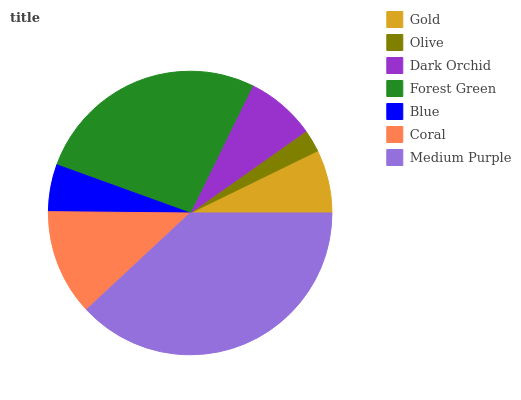Is Olive the minimum?
Answer yes or no. Yes. Is Medium Purple the maximum?
Answer yes or no. Yes. Is Dark Orchid the minimum?
Answer yes or no. No. Is Dark Orchid the maximum?
Answer yes or no. No. Is Dark Orchid greater than Olive?
Answer yes or no. Yes. Is Olive less than Dark Orchid?
Answer yes or no. Yes. Is Olive greater than Dark Orchid?
Answer yes or no. No. Is Dark Orchid less than Olive?
Answer yes or no. No. Is Dark Orchid the high median?
Answer yes or no. Yes. Is Dark Orchid the low median?
Answer yes or no. Yes. Is Forest Green the high median?
Answer yes or no. No. Is Forest Green the low median?
Answer yes or no. No. 